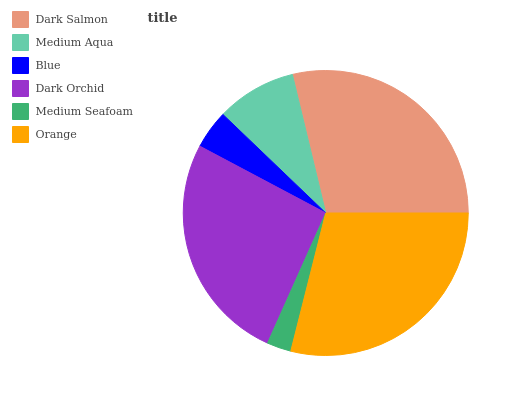Is Medium Seafoam the minimum?
Answer yes or no. Yes. Is Orange the maximum?
Answer yes or no. Yes. Is Medium Aqua the minimum?
Answer yes or no. No. Is Medium Aqua the maximum?
Answer yes or no. No. Is Dark Salmon greater than Medium Aqua?
Answer yes or no. Yes. Is Medium Aqua less than Dark Salmon?
Answer yes or no. Yes. Is Medium Aqua greater than Dark Salmon?
Answer yes or no. No. Is Dark Salmon less than Medium Aqua?
Answer yes or no. No. Is Dark Orchid the high median?
Answer yes or no. Yes. Is Medium Aqua the low median?
Answer yes or no. Yes. Is Orange the high median?
Answer yes or no. No. Is Blue the low median?
Answer yes or no. No. 